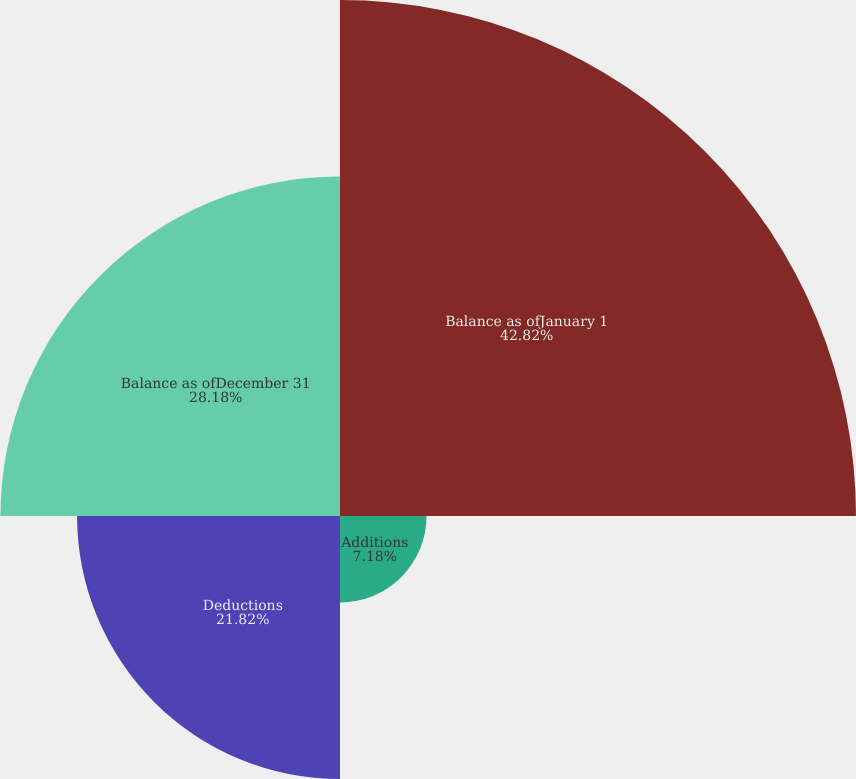Convert chart to OTSL. <chart><loc_0><loc_0><loc_500><loc_500><pie_chart><fcel>Balance as ofJanuary 1<fcel>Additions<fcel>Deductions<fcel>Balance as ofDecember 31<nl><fcel>42.82%<fcel>7.18%<fcel>21.82%<fcel>28.18%<nl></chart> 